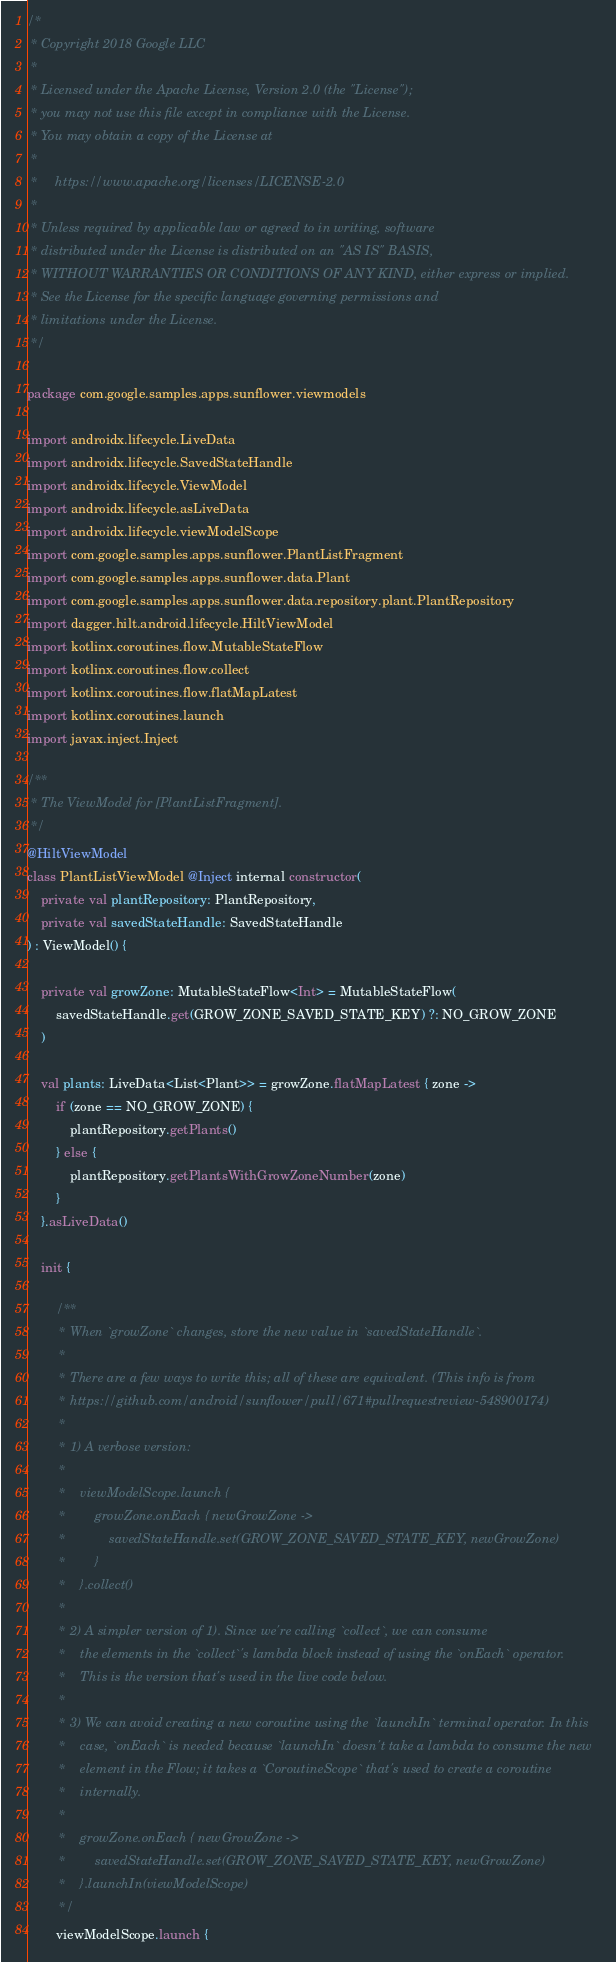Convert code to text. <code><loc_0><loc_0><loc_500><loc_500><_Kotlin_>/*
 * Copyright 2018 Google LLC
 *
 * Licensed under the Apache License, Version 2.0 (the "License");
 * you may not use this file except in compliance with the License.
 * You may obtain a copy of the License at
 *
 *     https://www.apache.org/licenses/LICENSE-2.0
 *
 * Unless required by applicable law or agreed to in writing, software
 * distributed under the License is distributed on an "AS IS" BASIS,
 * WITHOUT WARRANTIES OR CONDITIONS OF ANY KIND, either express or implied.
 * See the License for the specific language governing permissions and
 * limitations under the License.
 */

package com.google.samples.apps.sunflower.viewmodels

import androidx.lifecycle.LiveData
import androidx.lifecycle.SavedStateHandle
import androidx.lifecycle.ViewModel
import androidx.lifecycle.asLiveData
import androidx.lifecycle.viewModelScope
import com.google.samples.apps.sunflower.PlantListFragment
import com.google.samples.apps.sunflower.data.Plant
import com.google.samples.apps.sunflower.data.repository.plant.PlantRepository
import dagger.hilt.android.lifecycle.HiltViewModel
import kotlinx.coroutines.flow.MutableStateFlow
import kotlinx.coroutines.flow.collect
import kotlinx.coroutines.flow.flatMapLatest
import kotlinx.coroutines.launch
import javax.inject.Inject

/**
 * The ViewModel for [PlantListFragment].
 */
@HiltViewModel
class PlantListViewModel @Inject internal constructor(
    private val plantRepository: PlantRepository,
    private val savedStateHandle: SavedStateHandle
) : ViewModel() {

    private val growZone: MutableStateFlow<Int> = MutableStateFlow(
        savedStateHandle.get(GROW_ZONE_SAVED_STATE_KEY) ?: NO_GROW_ZONE
    )

    val plants: LiveData<List<Plant>> = growZone.flatMapLatest { zone ->
        if (zone == NO_GROW_ZONE) {
            plantRepository.getPlants()
        } else {
            plantRepository.getPlantsWithGrowZoneNumber(zone)
        }
    }.asLiveData()

    init {

        /**
         * When `growZone` changes, store the new value in `savedStateHandle`.
         *
         * There are a few ways to write this; all of these are equivalent. (This info is from
         * https://github.com/android/sunflower/pull/671#pullrequestreview-548900174)
         *
         * 1) A verbose version:
         *
         *    viewModelScope.launch {
         *        growZone.onEach { newGrowZone ->
         *            savedStateHandle.set(GROW_ZONE_SAVED_STATE_KEY, newGrowZone)
         *        }
         *    }.collect()
         *
         * 2) A simpler version of 1). Since we're calling `collect`, we can consume
         *    the elements in the `collect`'s lambda block instead of using the `onEach` operator.
         *    This is the version that's used in the live code below.
         *
         * 3) We can avoid creating a new coroutine using the `launchIn` terminal operator. In this
         *    case, `onEach` is needed because `launchIn` doesn't take a lambda to consume the new
         *    element in the Flow; it takes a `CoroutineScope` that's used to create a coroutine
         *    internally.
         *
         *    growZone.onEach { newGrowZone ->
         *        savedStateHandle.set(GROW_ZONE_SAVED_STATE_KEY, newGrowZone)
         *    }.launchIn(viewModelScope)
         */
        viewModelScope.launch {</code> 